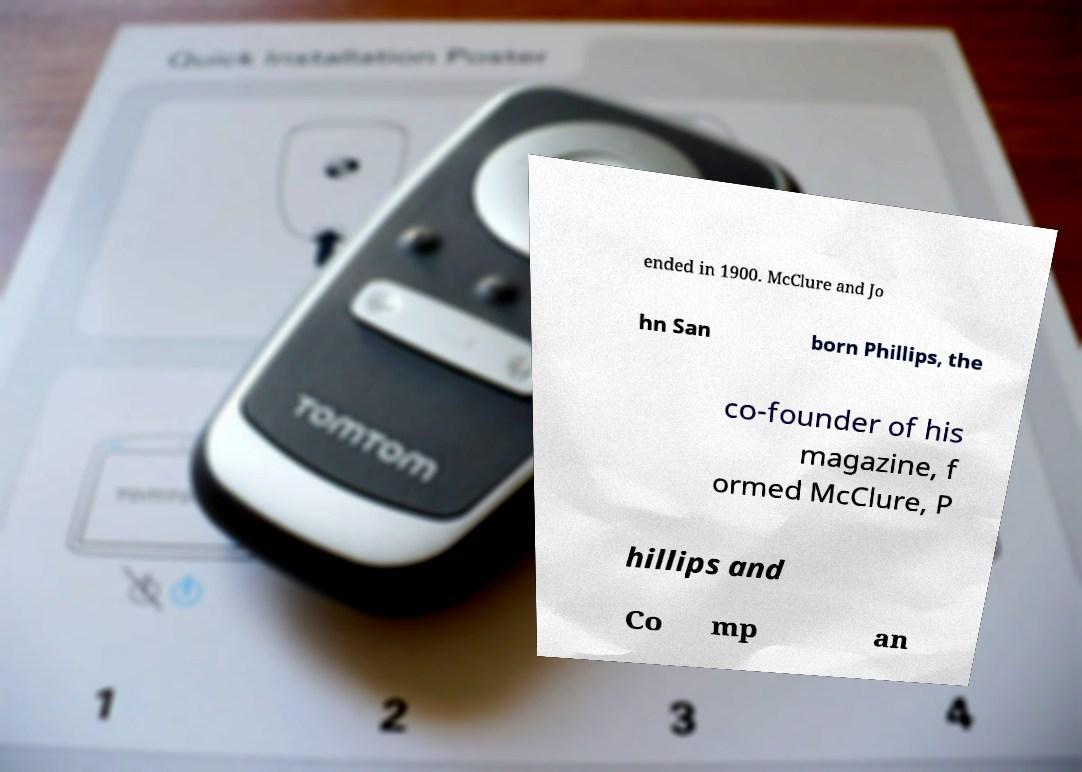Could you assist in decoding the text presented in this image and type it out clearly? ended in 1900. McClure and Jo hn San born Phillips, the co-founder of his magazine, f ormed McClure, P hillips and Co mp an 